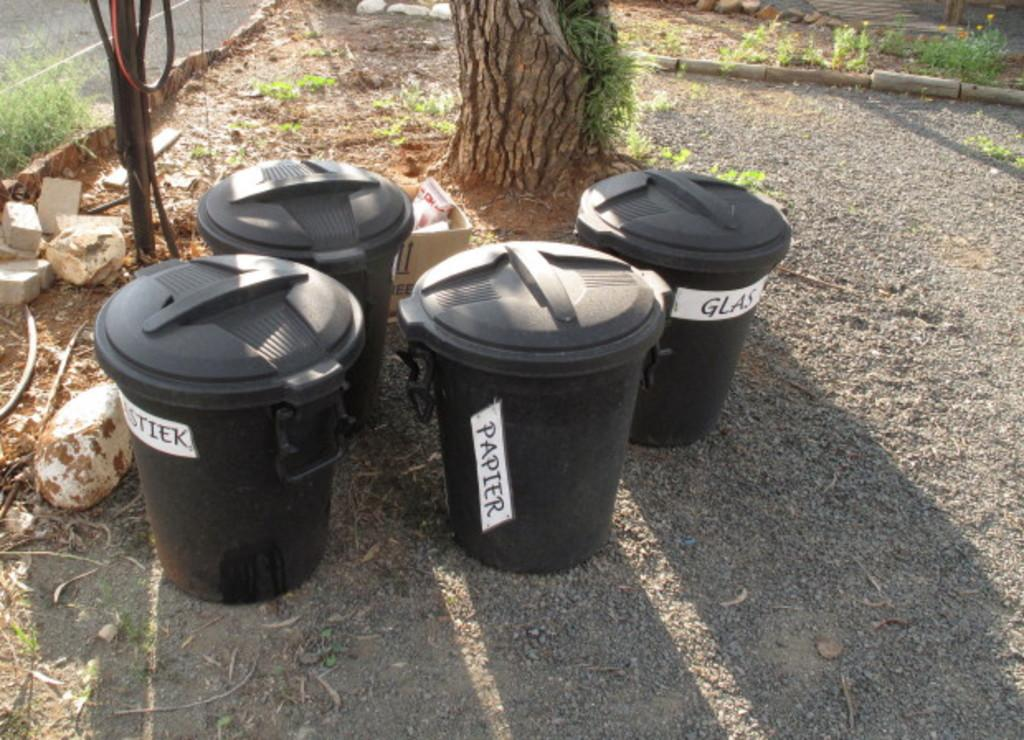<image>
Describe the image concisely. Four different bins are outside with labels such as "papier". 